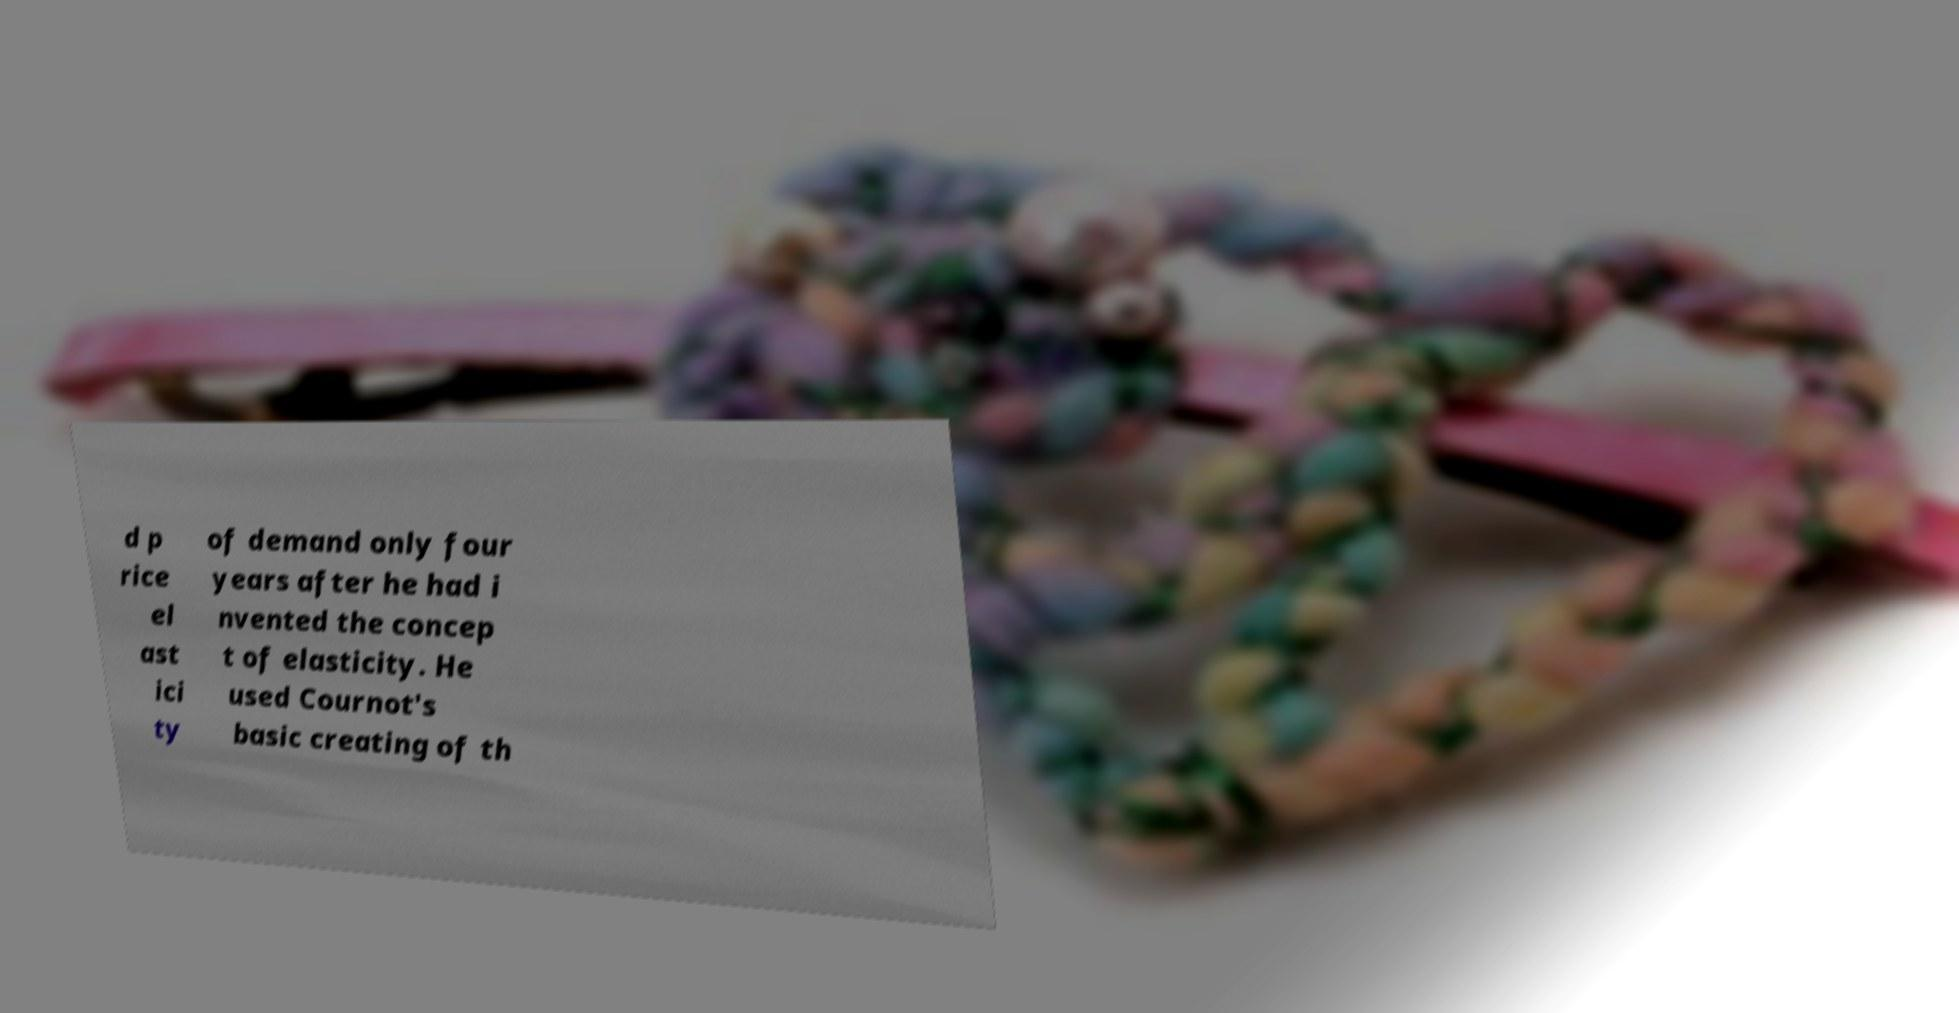There's text embedded in this image that I need extracted. Can you transcribe it verbatim? d p rice el ast ici ty of demand only four years after he had i nvented the concep t of elasticity. He used Cournot's basic creating of th 